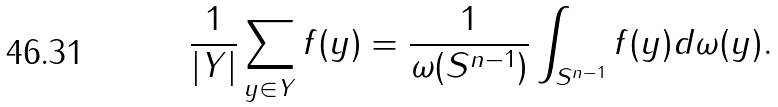<formula> <loc_0><loc_0><loc_500><loc_500>\frac { 1 } { | Y | } \sum _ { y \in Y } f ( y ) = \frac { 1 } { \omega ( S ^ { n - 1 } ) } \int _ { S ^ { n - 1 } } f ( y ) d \omega ( y ) .</formula> 